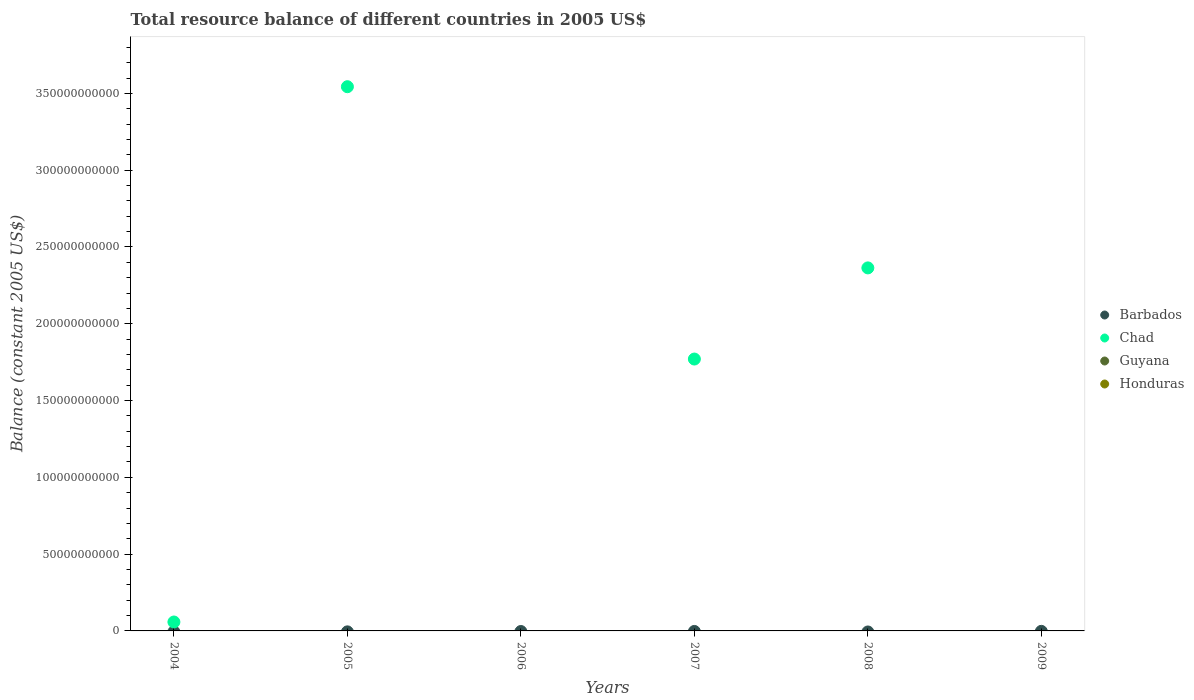How many different coloured dotlines are there?
Ensure brevity in your answer.  1. Is the number of dotlines equal to the number of legend labels?
Offer a terse response. No. What is the total resource balance in Chad in 2004?
Provide a succinct answer. 5.81e+09. Across all years, what is the maximum total resource balance in Chad?
Your answer should be compact. 3.54e+11. Across all years, what is the minimum total resource balance in Guyana?
Ensure brevity in your answer.  0. What is the difference between the total resource balance in Chad in 2005 and that in 2007?
Keep it short and to the point. 1.77e+11. What is the difference between the total resource balance in Chad in 2004 and the total resource balance in Honduras in 2005?
Your answer should be very brief. 5.81e+09. What is the difference between the highest and the second highest total resource balance in Chad?
Your answer should be compact. 1.18e+11. What is the difference between the highest and the lowest total resource balance in Chad?
Keep it short and to the point. 3.54e+11. Is it the case that in every year, the sum of the total resource balance in Honduras and total resource balance in Barbados  is greater than the sum of total resource balance in Guyana and total resource balance in Chad?
Give a very brief answer. No. What is the difference between two consecutive major ticks on the Y-axis?
Your answer should be very brief. 5.00e+1. Are the values on the major ticks of Y-axis written in scientific E-notation?
Your answer should be very brief. No. Does the graph contain grids?
Keep it short and to the point. No. Where does the legend appear in the graph?
Your answer should be very brief. Center right. How many legend labels are there?
Your answer should be very brief. 4. What is the title of the graph?
Your answer should be compact. Total resource balance of different countries in 2005 US$. Does "High income: nonOECD" appear as one of the legend labels in the graph?
Ensure brevity in your answer.  No. What is the label or title of the X-axis?
Make the answer very short. Years. What is the label or title of the Y-axis?
Offer a terse response. Balance (constant 2005 US$). What is the Balance (constant 2005 US$) in Barbados in 2004?
Keep it short and to the point. 0. What is the Balance (constant 2005 US$) in Chad in 2004?
Offer a very short reply. 5.81e+09. What is the Balance (constant 2005 US$) in Guyana in 2004?
Ensure brevity in your answer.  0. What is the Balance (constant 2005 US$) of Honduras in 2004?
Your answer should be very brief. 0. What is the Balance (constant 2005 US$) of Chad in 2005?
Give a very brief answer. 3.54e+11. What is the Balance (constant 2005 US$) in Guyana in 2005?
Ensure brevity in your answer.  0. What is the Balance (constant 2005 US$) of Barbados in 2006?
Provide a short and direct response. 0. What is the Balance (constant 2005 US$) in Honduras in 2006?
Offer a very short reply. 0. What is the Balance (constant 2005 US$) in Barbados in 2007?
Keep it short and to the point. 0. What is the Balance (constant 2005 US$) of Chad in 2007?
Keep it short and to the point. 1.77e+11. What is the Balance (constant 2005 US$) of Guyana in 2007?
Ensure brevity in your answer.  0. What is the Balance (constant 2005 US$) of Honduras in 2007?
Your response must be concise. 0. What is the Balance (constant 2005 US$) in Barbados in 2008?
Provide a succinct answer. 0. What is the Balance (constant 2005 US$) of Chad in 2008?
Your answer should be very brief. 2.36e+11. What is the Balance (constant 2005 US$) in Honduras in 2008?
Make the answer very short. 0. What is the Balance (constant 2005 US$) of Barbados in 2009?
Ensure brevity in your answer.  0. What is the Balance (constant 2005 US$) of Guyana in 2009?
Offer a terse response. 0. What is the Balance (constant 2005 US$) of Honduras in 2009?
Offer a very short reply. 0. Across all years, what is the maximum Balance (constant 2005 US$) in Chad?
Your answer should be very brief. 3.54e+11. What is the total Balance (constant 2005 US$) of Chad in the graph?
Give a very brief answer. 7.74e+11. What is the total Balance (constant 2005 US$) in Guyana in the graph?
Provide a succinct answer. 0. What is the difference between the Balance (constant 2005 US$) in Chad in 2004 and that in 2005?
Your answer should be very brief. -3.49e+11. What is the difference between the Balance (constant 2005 US$) in Chad in 2004 and that in 2007?
Ensure brevity in your answer.  -1.71e+11. What is the difference between the Balance (constant 2005 US$) of Chad in 2004 and that in 2008?
Provide a short and direct response. -2.31e+11. What is the difference between the Balance (constant 2005 US$) in Chad in 2005 and that in 2007?
Offer a very short reply. 1.77e+11. What is the difference between the Balance (constant 2005 US$) of Chad in 2005 and that in 2008?
Ensure brevity in your answer.  1.18e+11. What is the difference between the Balance (constant 2005 US$) of Chad in 2007 and that in 2008?
Provide a succinct answer. -5.94e+1. What is the average Balance (constant 2005 US$) of Chad per year?
Give a very brief answer. 1.29e+11. What is the ratio of the Balance (constant 2005 US$) in Chad in 2004 to that in 2005?
Provide a succinct answer. 0.02. What is the ratio of the Balance (constant 2005 US$) in Chad in 2004 to that in 2007?
Offer a very short reply. 0.03. What is the ratio of the Balance (constant 2005 US$) of Chad in 2004 to that in 2008?
Make the answer very short. 0.02. What is the ratio of the Balance (constant 2005 US$) of Chad in 2005 to that in 2007?
Your answer should be compact. 2. What is the ratio of the Balance (constant 2005 US$) of Chad in 2005 to that in 2008?
Offer a terse response. 1.5. What is the ratio of the Balance (constant 2005 US$) in Chad in 2007 to that in 2008?
Give a very brief answer. 0.75. What is the difference between the highest and the second highest Balance (constant 2005 US$) in Chad?
Offer a very short reply. 1.18e+11. What is the difference between the highest and the lowest Balance (constant 2005 US$) of Chad?
Give a very brief answer. 3.54e+11. 